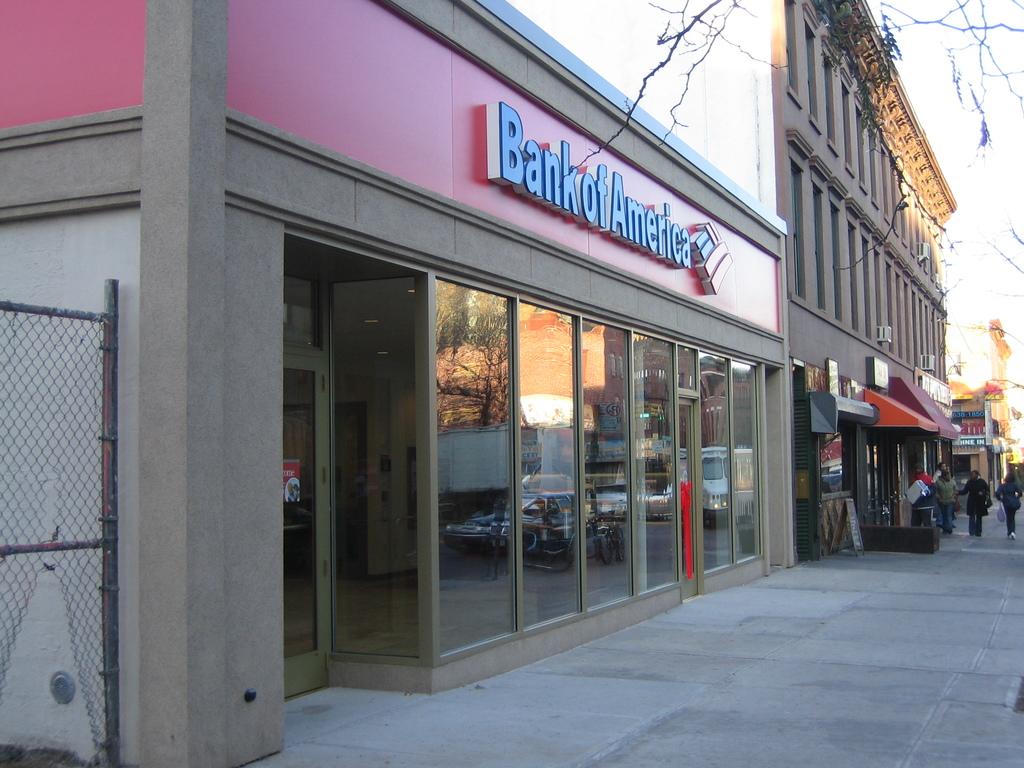What bank is this?
Your answer should be very brief. Bank of america. 